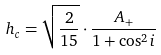Convert formula to latex. <formula><loc_0><loc_0><loc_500><loc_500>h _ { c } = \sqrt { \frac { 2 } { 1 5 } } \cdot \frac { A _ { + } } { 1 + \cos ^ { 2 } { i } }</formula> 